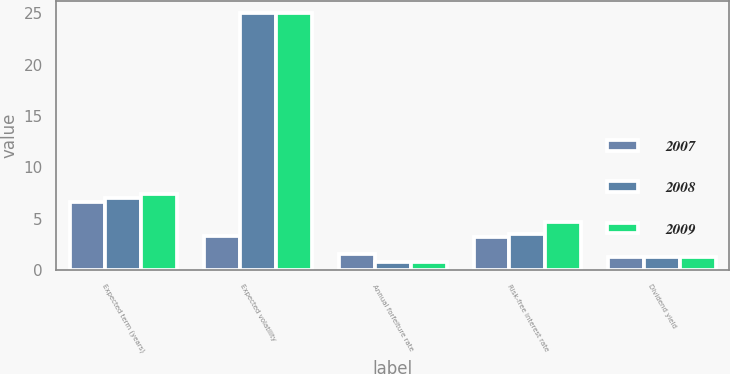Convert chart to OTSL. <chart><loc_0><loc_0><loc_500><loc_500><stacked_bar_chart><ecel><fcel>Expected term (years)<fcel>Expected volatility<fcel>Annual forfeiture rate<fcel>Risk-free interest rate<fcel>Dividend yield<nl><fcel>2007<fcel>6.6<fcel>3.35<fcel>1.6<fcel>3.2<fcel>1.3<nl><fcel>2008<fcel>7<fcel>25<fcel>0.8<fcel>3.5<fcel>1.3<nl><fcel>2009<fcel>7.4<fcel>25<fcel>0.8<fcel>4.7<fcel>1.3<nl></chart> 